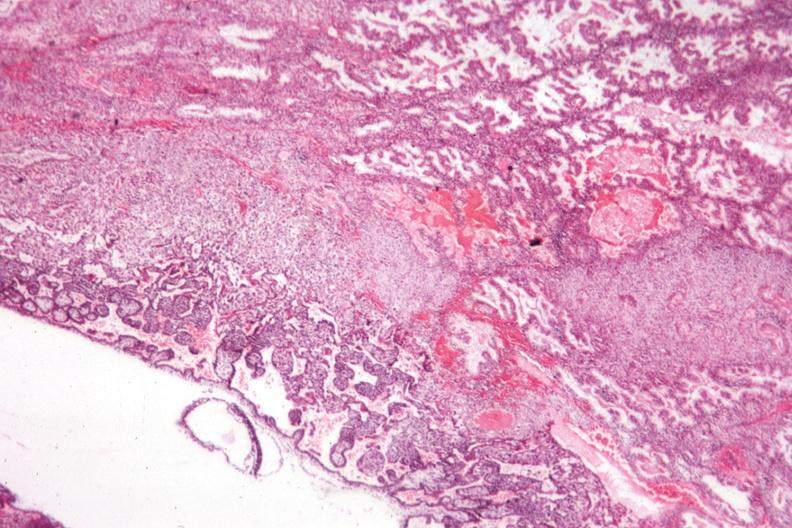s uterus present?
Answer the question using a single word or phrase. Yes 